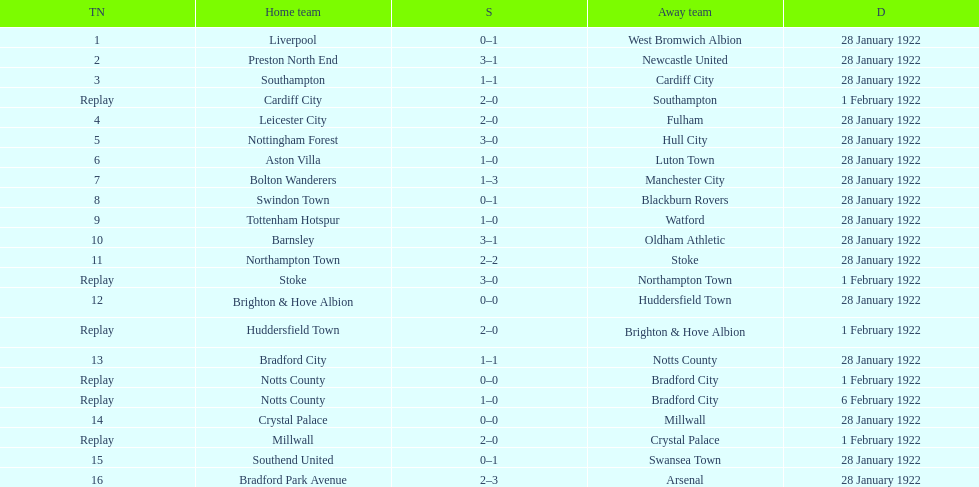Who is the first home team listed as having a score of 3-1? Preston North End. 